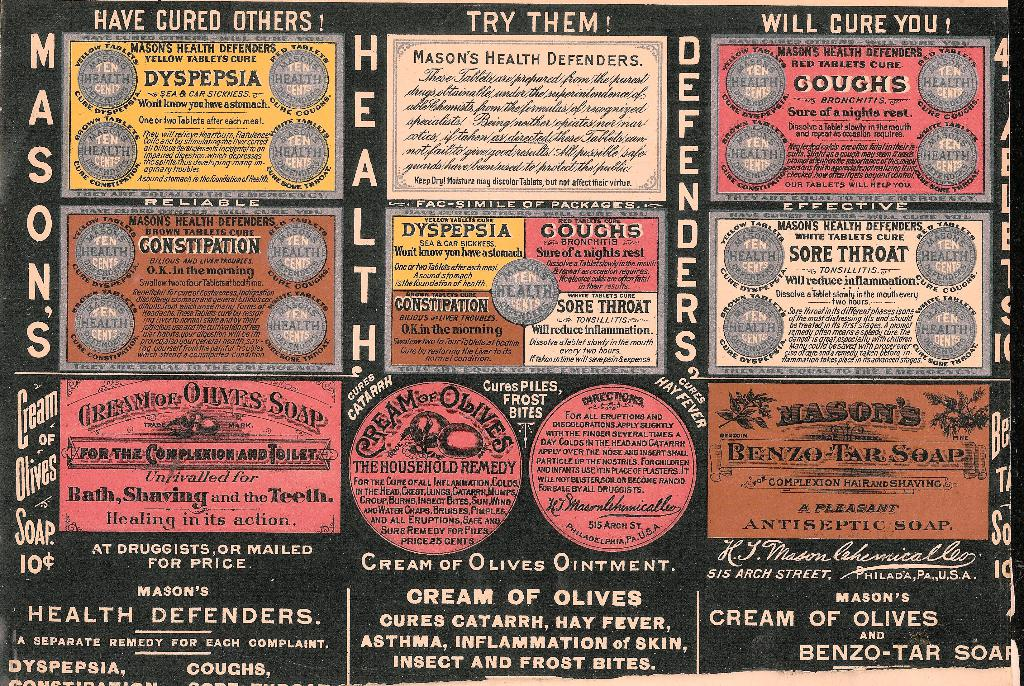Provide a one-sentence caption for the provided image.
Reference OCR token: HAVE, CURED, OTHERS, THEM, CURE, YOU, H, MASON'S, HEALTH, D, DYSPEPSIA, SEA&CARS/CRNESS., E, GOUGHS, E, E, GOUGHS, GONSTIPATION, ABLETSCURE, THROAT, CONSTURATION, R, S, H, S, MOR, OLYES, SOAP, MASONS, Olives, BENZO-TARSOA, SOAP, ivalledfor, Shaving, @COMPLEXIONHAIRANDSHAVING, SOAP, Healing, action., EPTIC, SOAP, 10$, DRUGG, STS, MAILED, LADELPRIAPA.UA, CREAM, OLIVES, INTMENT., Cohemicalloo, MASON'S, OF, DEFENDERS., CURES, CATARRH,, FEVER,, CREAM, OF, OLIVES, SEPARATE, REMEDY, COMPLAINT., ASTHMA,, LAMMATION, SKIN,, DYSPEPSIA., COUGHS,, INSECT, FROST, BITES, BENZO-TAR, SOA a page that says 'mason's health defenders' on it. 